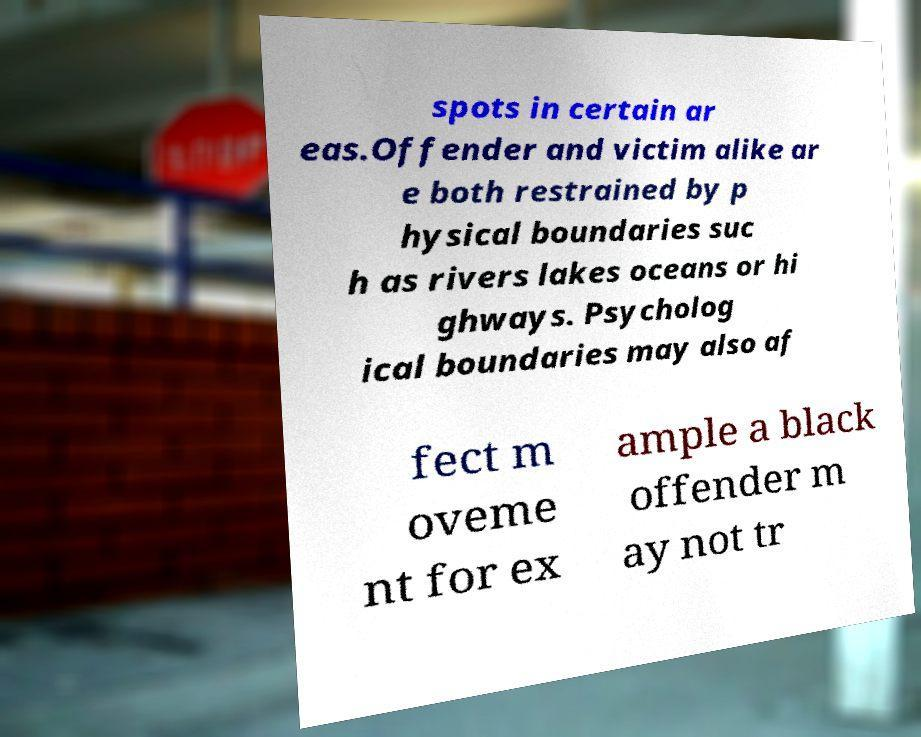There's text embedded in this image that I need extracted. Can you transcribe it verbatim? spots in certain ar eas.Offender and victim alike ar e both restrained by p hysical boundaries suc h as rivers lakes oceans or hi ghways. Psycholog ical boundaries may also af fect m oveme nt for ex ample a black offender m ay not tr 